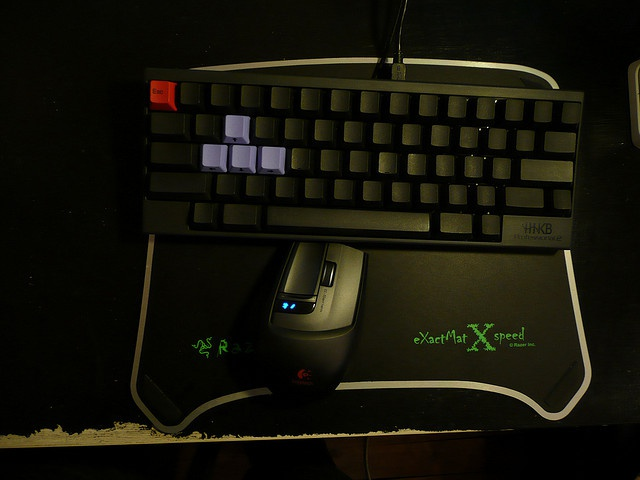Describe the objects in this image and their specific colors. I can see keyboard in black, darkgreen, and gray tones and mouse in black and olive tones in this image. 